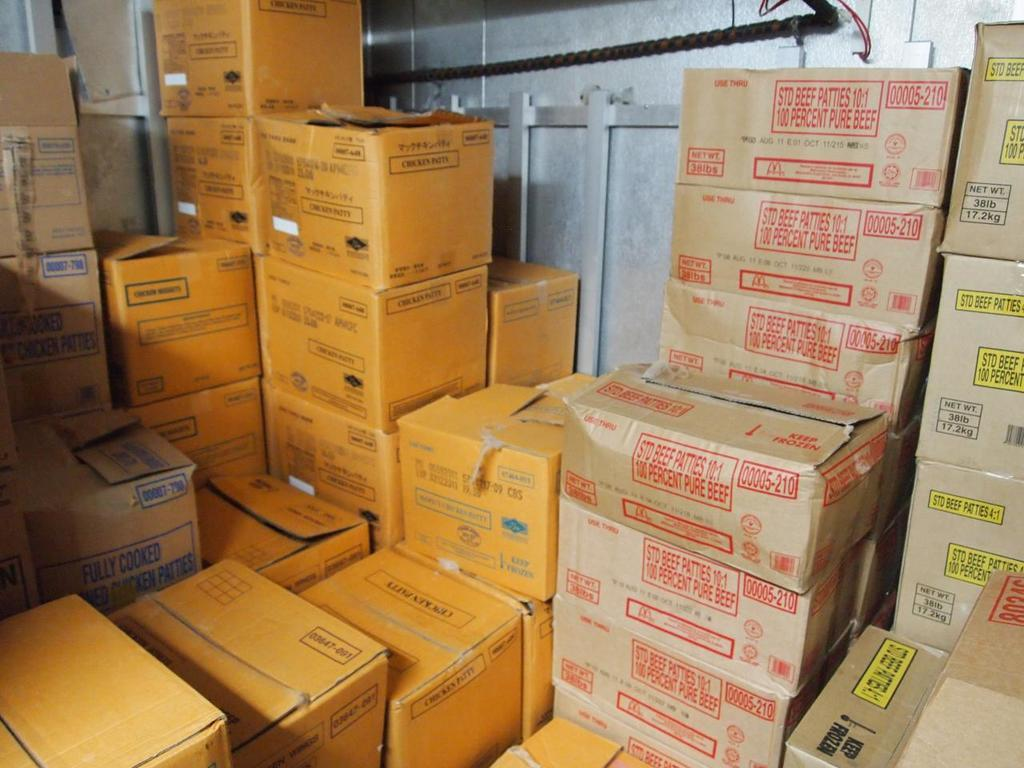<image>
Describe the image concisely. Boxes full of chicken patties and beef products 